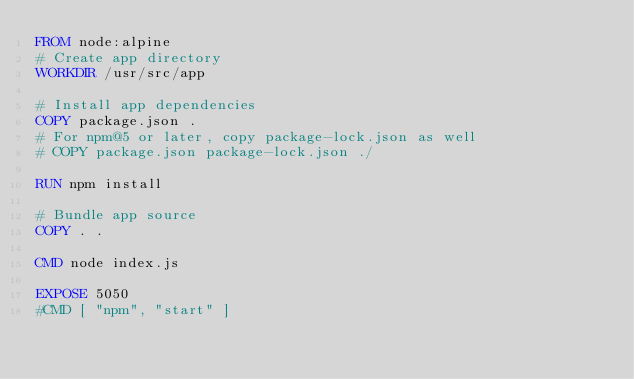Convert code to text. <code><loc_0><loc_0><loc_500><loc_500><_Dockerfile_>FROM node:alpine
# Create app directory
WORKDIR /usr/src/app

# Install app dependencies
COPY package.json .
# For npm@5 or later, copy package-lock.json as well
# COPY package.json package-lock.json ./

RUN npm install

# Bundle app source
COPY . .

CMD node index.js

EXPOSE 5050
#CMD [ "npm", "start" ]

</code> 